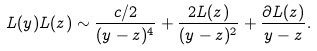Convert formula to latex. <formula><loc_0><loc_0><loc_500><loc_500>L ( y ) L ( z ) \sim \frac { c / 2 } { ( y - z ) ^ { 4 } } + \frac { 2 L ( z ) } { ( y - z ) ^ { 2 } } + \frac { \partial L ( z ) } { y - z } .</formula> 